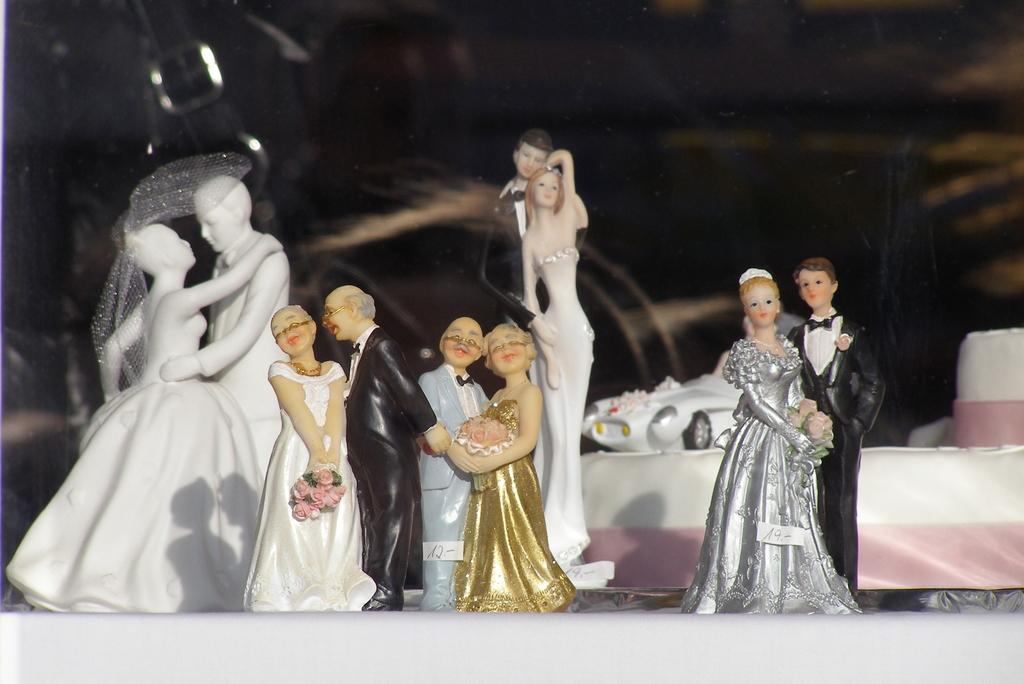How many couple sculptures are on the platform in the image? There are five couple sculptures on the platform in the image. What can be seen in the background of the image? In the background, there is a toy car. Are there any other objects visible in the background? Yes, there are other unspecified items visible in the background. What type of territory does the queen claim in the image? There is no queen or territory present in the image. The image features five couple sculptures on a platform and a toy car in the background. 